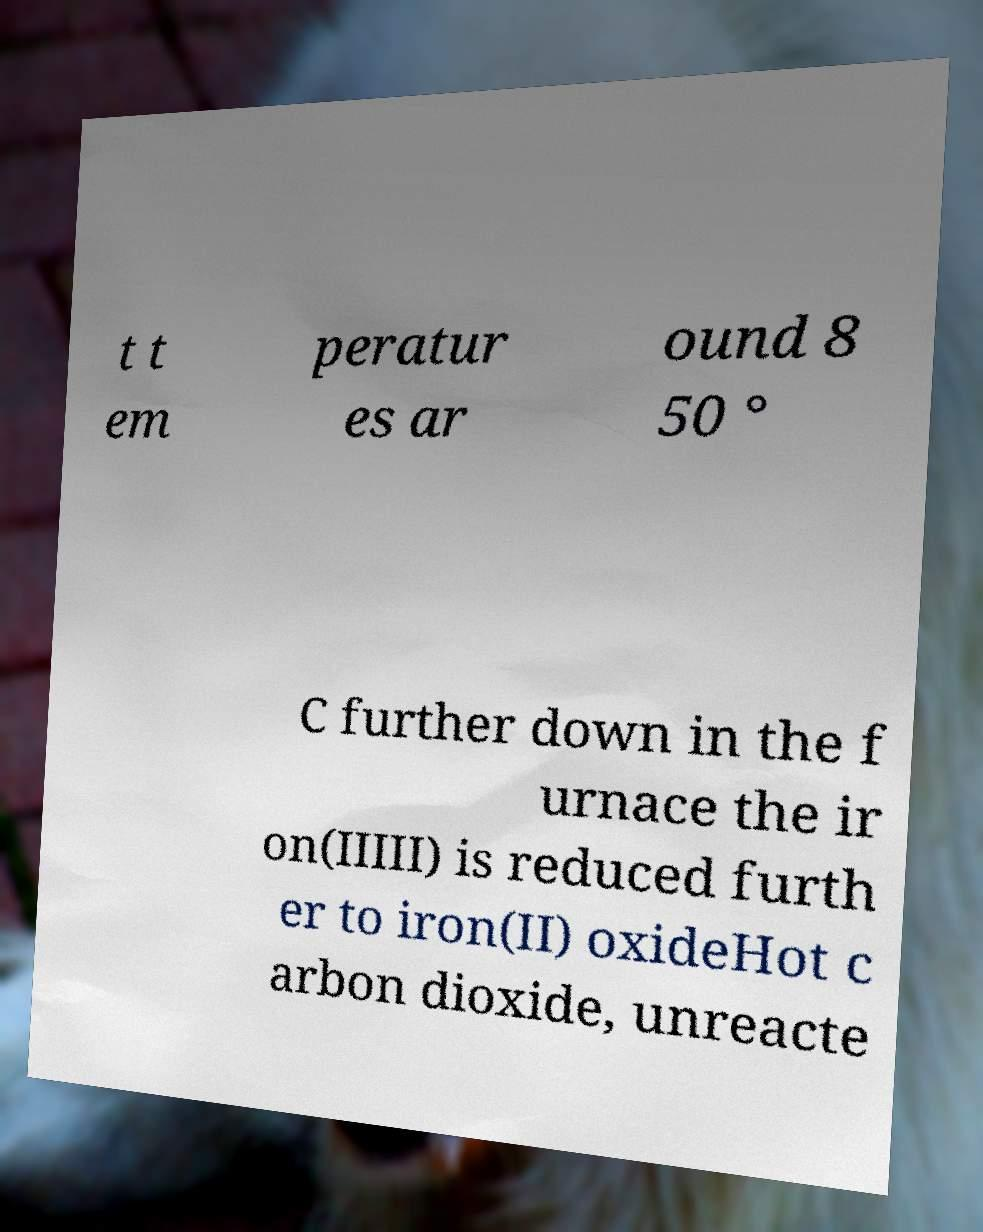Can you accurately transcribe the text from the provided image for me? t t em peratur es ar ound 8 50 ° C further down in the f urnace the ir on(IIIII) is reduced furth er to iron(II) oxideHot c arbon dioxide, unreacte 